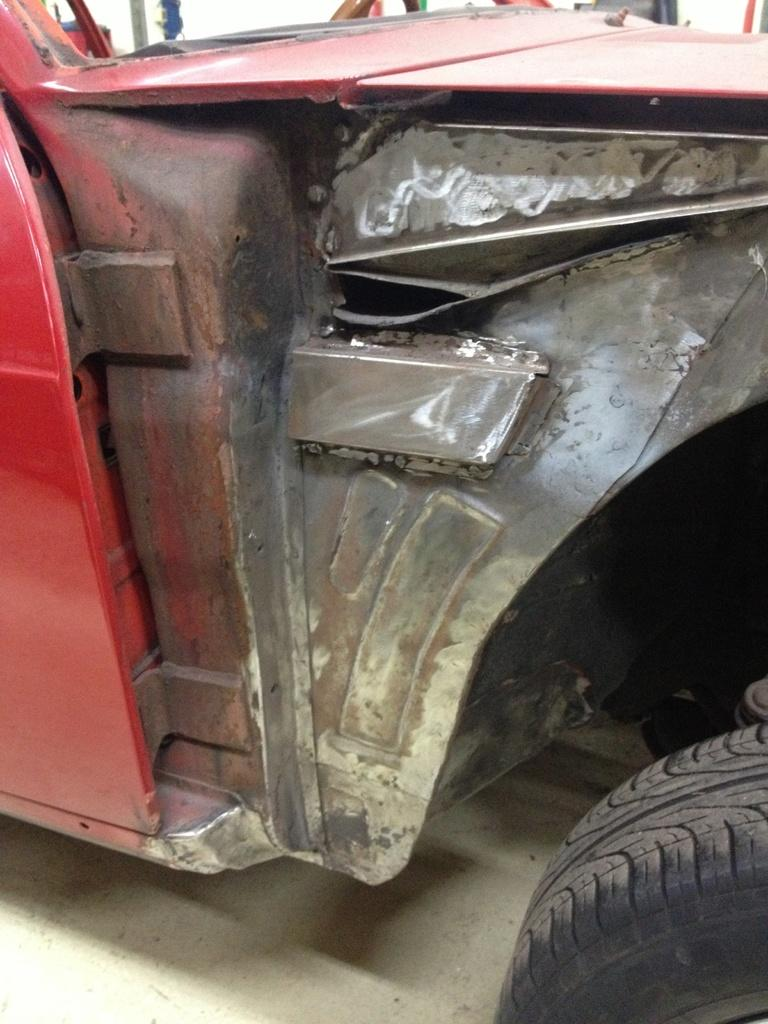What color is the vehicle in the picture? The vehicle in the picture is red. Can you describe any other objects in the picture? There is a tyre on the bottom right side of the picture. What type of group activity is happening with the snail in the picture? There is no snail present in the picture, so it is not possible to answer that question. 